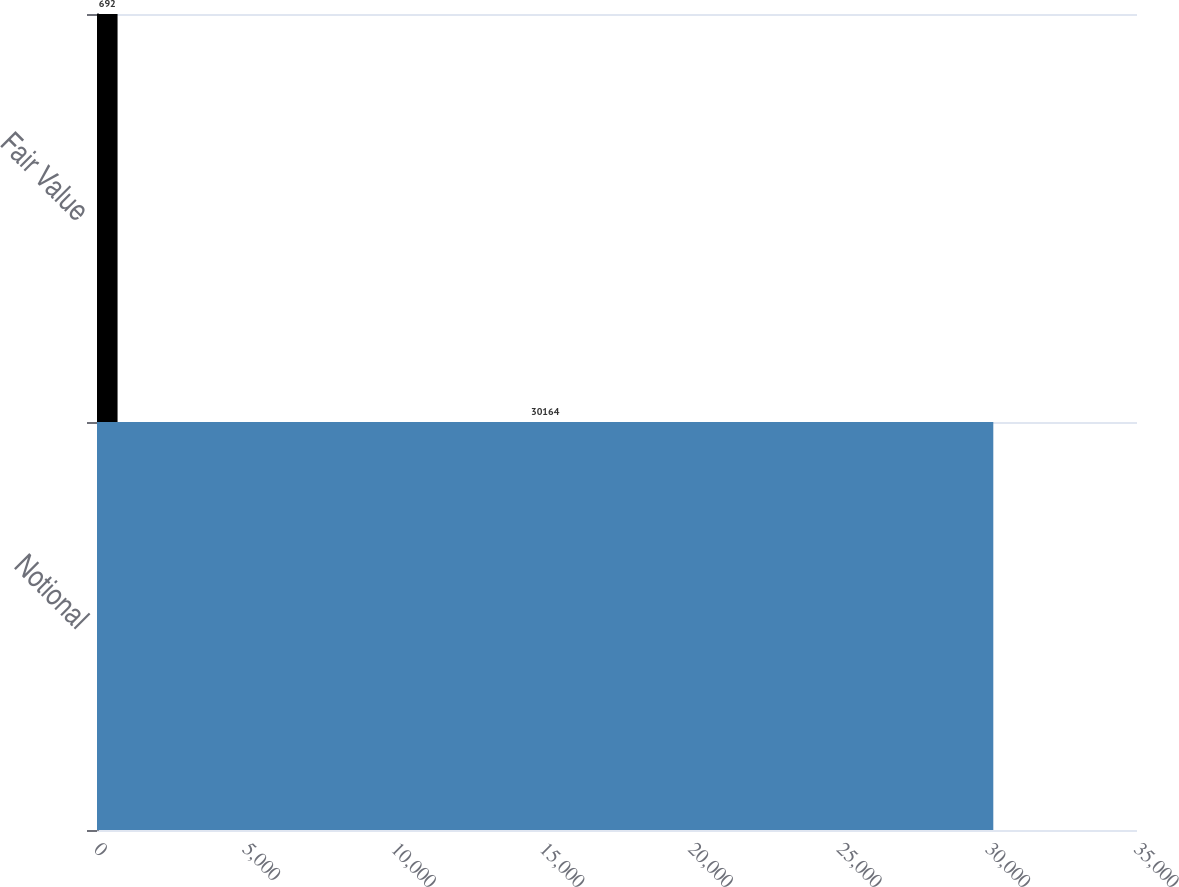<chart> <loc_0><loc_0><loc_500><loc_500><bar_chart><fcel>Notional<fcel>Fair Value<nl><fcel>30164<fcel>692<nl></chart> 